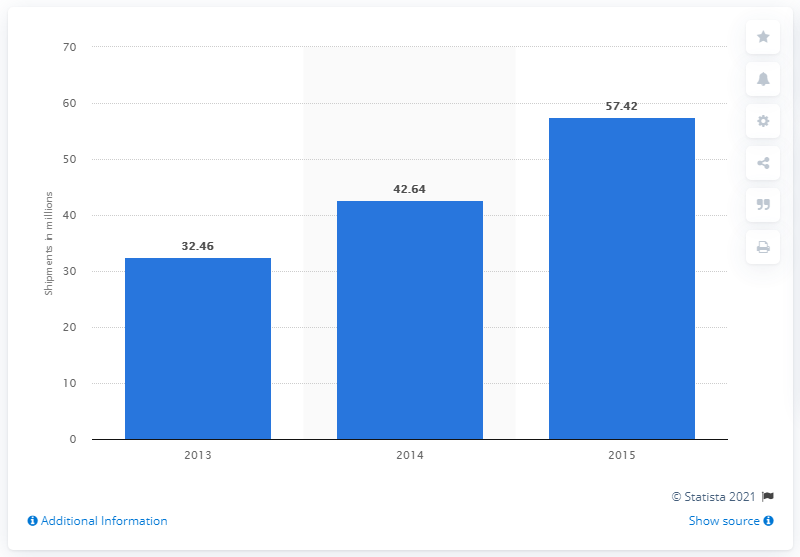Give some essential details in this illustration. As of 2015, it is forecasted that 57.42 wearable sports/activity tracking devices will be shipped. 